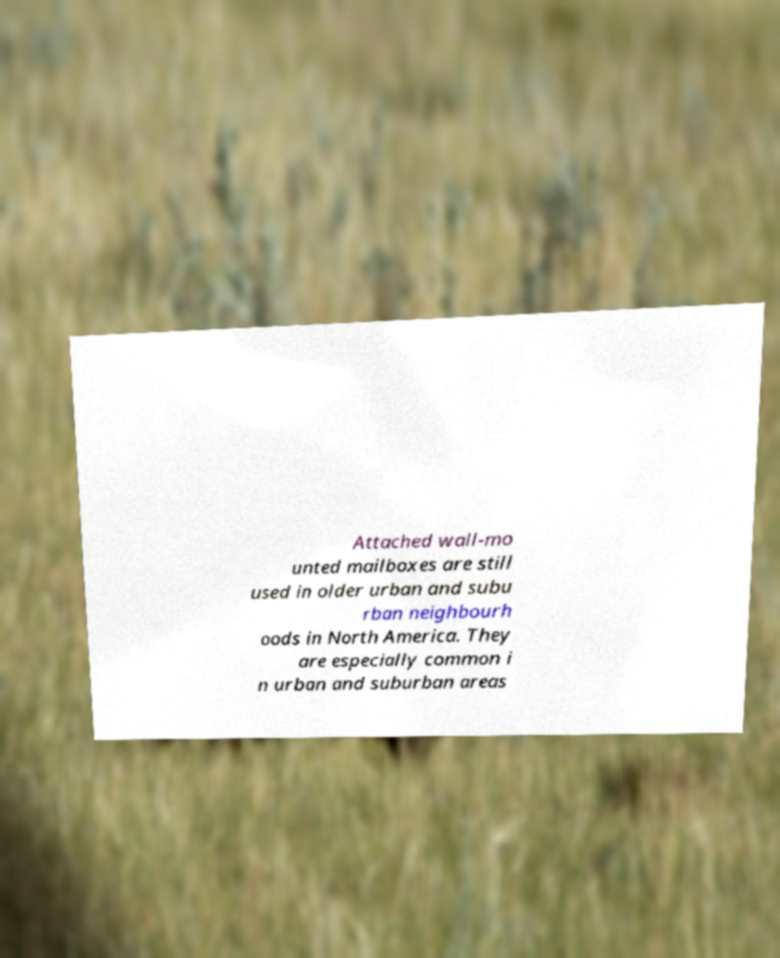Can you accurately transcribe the text from the provided image for me? Attached wall-mo unted mailboxes are still used in older urban and subu rban neighbourh oods in North America. They are especially common i n urban and suburban areas 